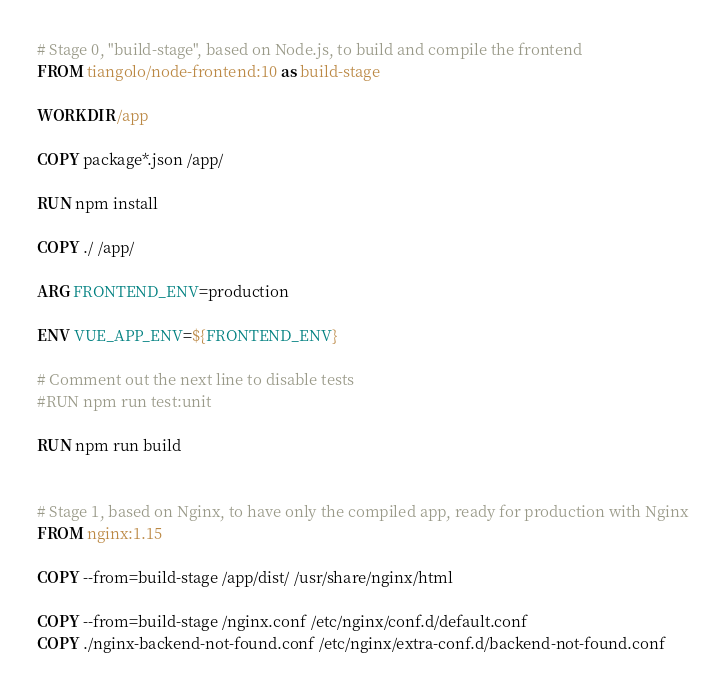Convert code to text. <code><loc_0><loc_0><loc_500><loc_500><_Dockerfile_># Stage 0, "build-stage", based on Node.js, to build and compile the frontend
FROM tiangolo/node-frontend:10 as build-stage

WORKDIR /app

COPY package*.json /app/

RUN npm install

COPY ./ /app/

ARG FRONTEND_ENV=production

ENV VUE_APP_ENV=${FRONTEND_ENV}

# Comment out the next line to disable tests
#RUN npm run test:unit

RUN npm run build


# Stage 1, based on Nginx, to have only the compiled app, ready for production with Nginx
FROM nginx:1.15

COPY --from=build-stage /app/dist/ /usr/share/nginx/html

COPY --from=build-stage /nginx.conf /etc/nginx/conf.d/default.conf
COPY ./nginx-backend-not-found.conf /etc/nginx/extra-conf.d/backend-not-found.conf
</code> 